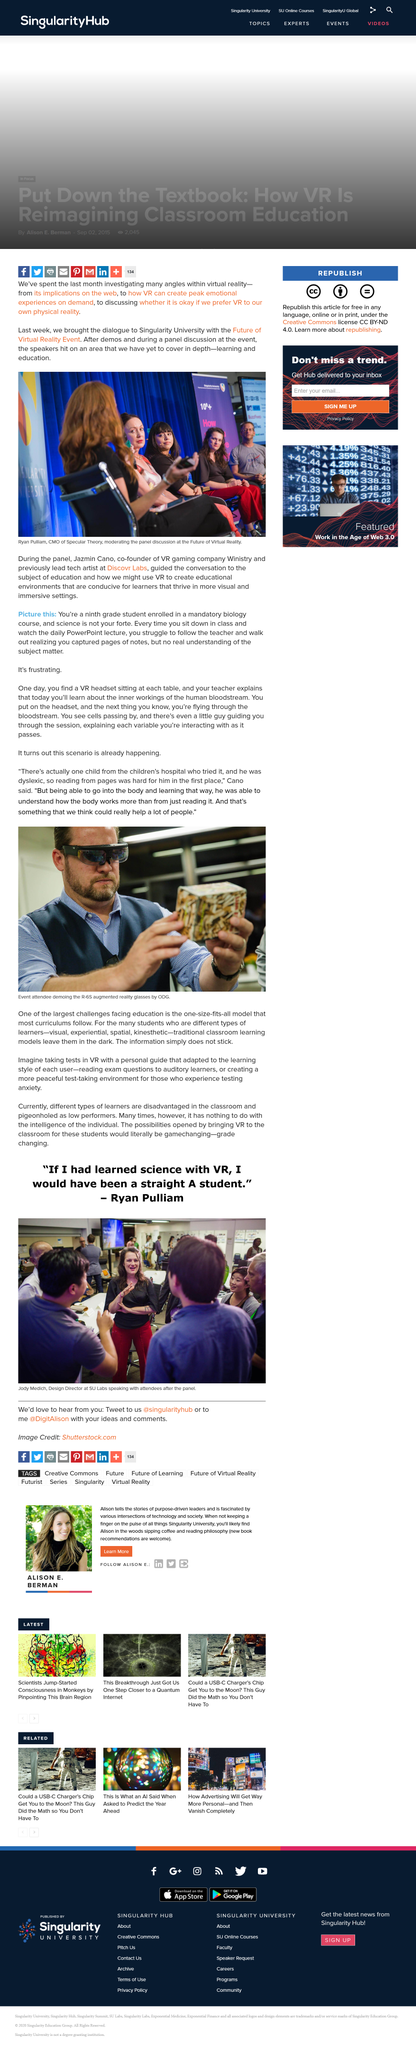Mention a couple of crucial points in this snapshot. There are various types of learning, including visual, experiential, spatial, and kinesthetic learning. The lady in the center, wearing red trousers, is Jody Medich, a Design Director who is involved in Virtual Reality learning. One of the largest challenges facing education is the use of a one-size-fits-all approach in curriculums, which fails to meet the diverse needs and abilities of students. Winistry's co-founder is Jazmin Cano. Jody Medich works at the SU Labs. 